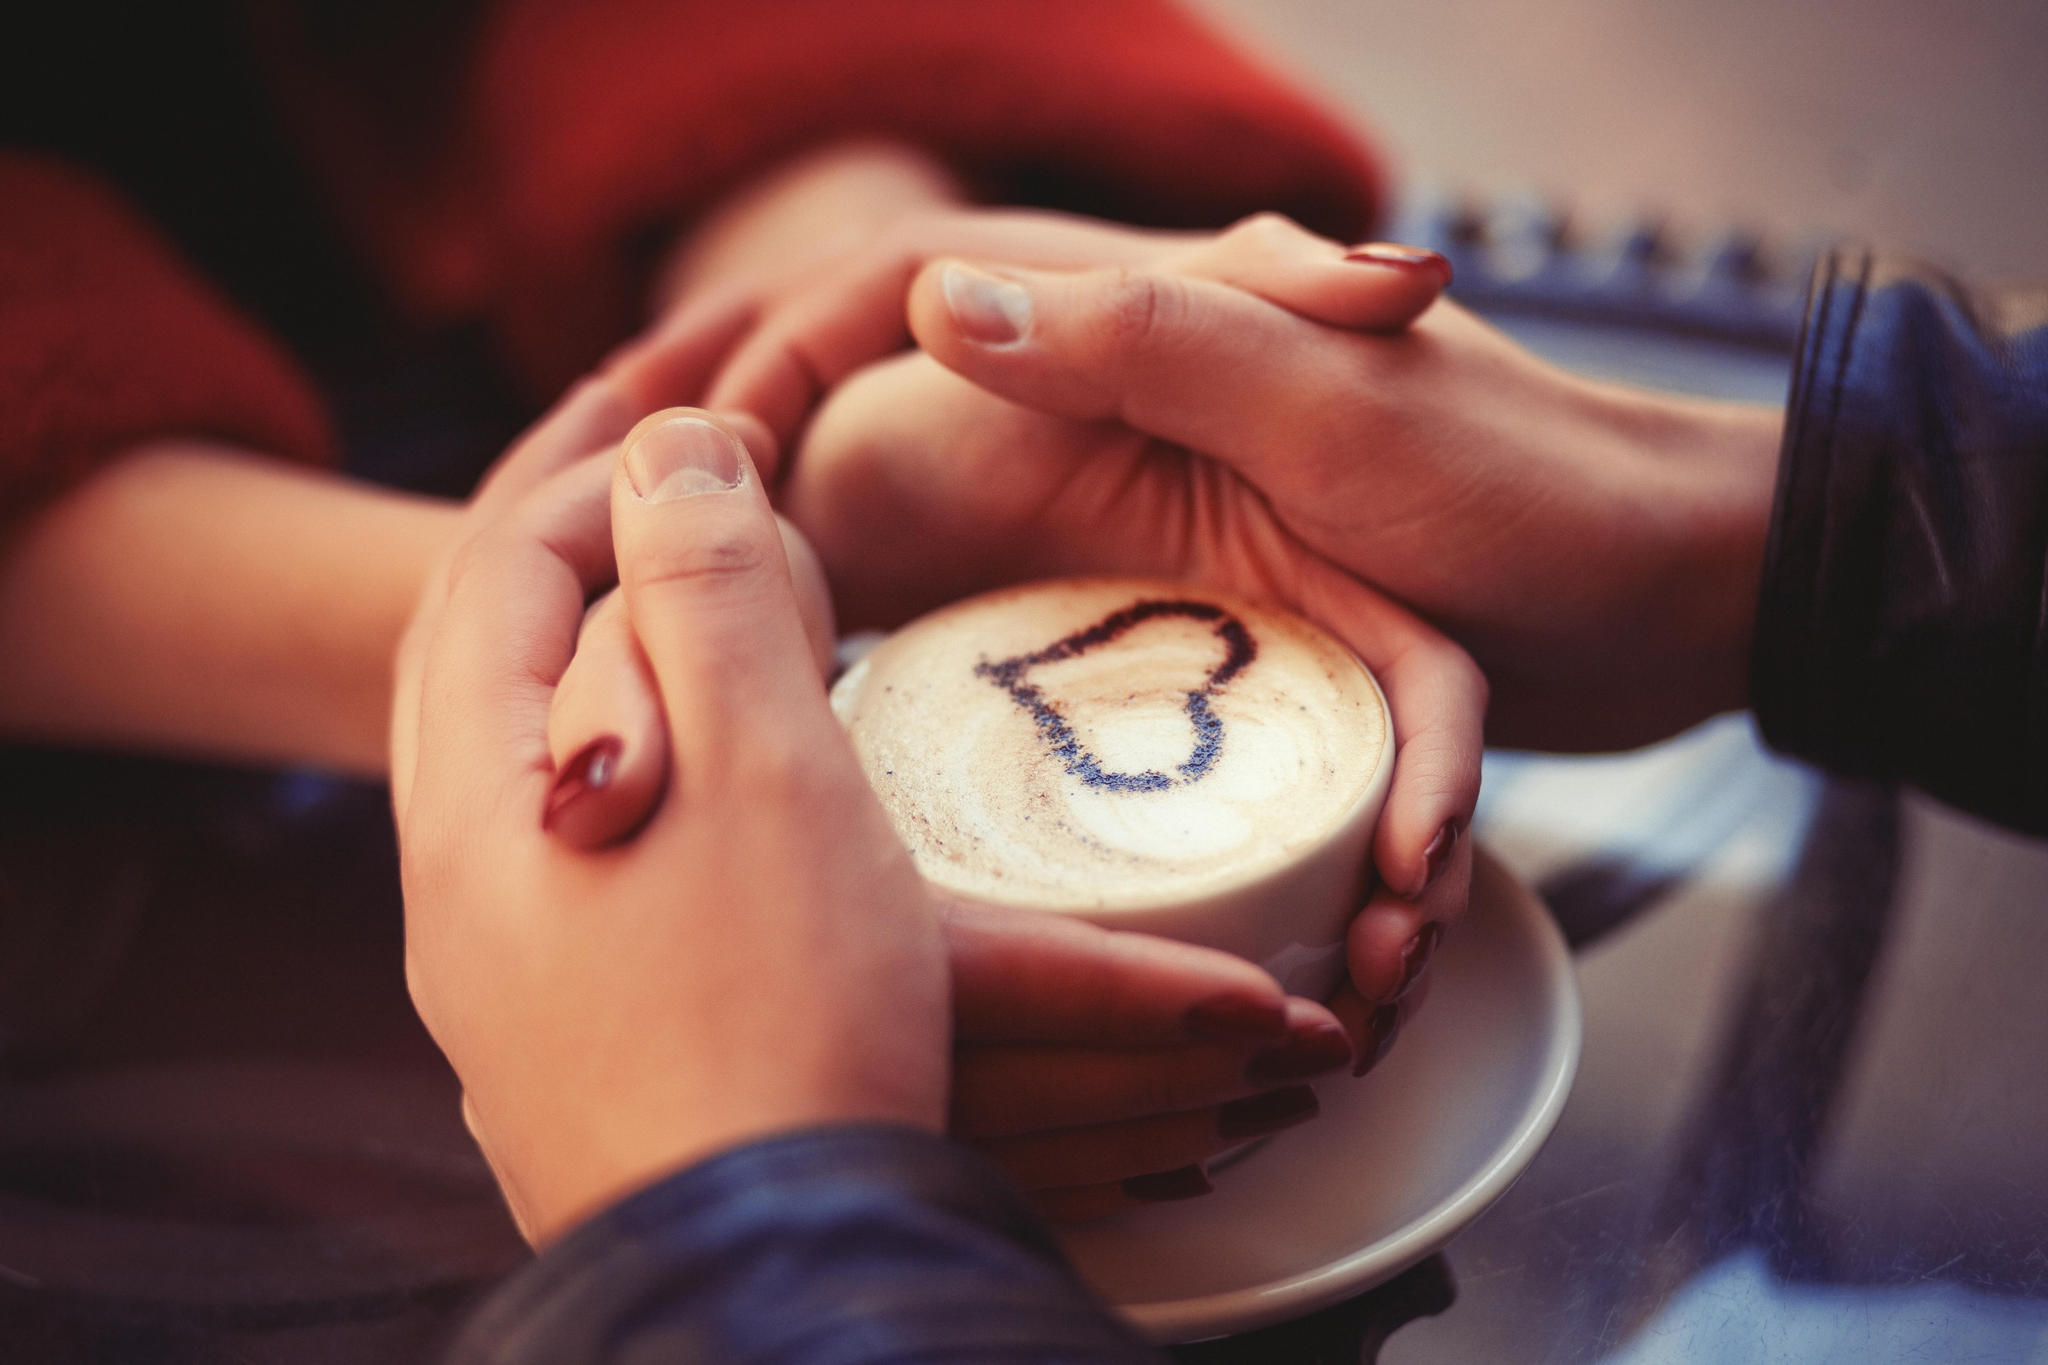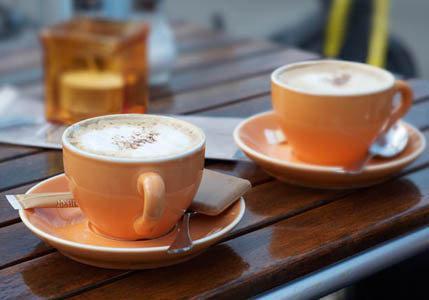The first image is the image on the left, the second image is the image on the right. Examine the images to the left and right. Is the description "Only one image includes human hands with mugs of hot beverages." accurate? Answer yes or no. Yes. The first image is the image on the left, the second image is the image on the right. Considering the images on both sides, is "One image shows human hands wrapped around a cup." valid? Answer yes or no. Yes. 